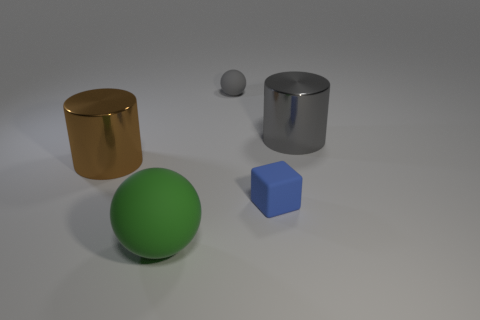Add 2 brown objects. How many objects exist? 7 Subtract all gray spheres. How many spheres are left? 1 Subtract all spheres. How many objects are left? 3 Subtract 1 cylinders. How many cylinders are left? 1 Subtract all gray cylinders. Subtract all blue balls. How many cylinders are left? 1 Subtract all blue cylinders. How many gray balls are left? 1 Subtract all small purple balls. Subtract all cylinders. How many objects are left? 3 Add 4 cylinders. How many cylinders are left? 6 Add 2 tiny blue cylinders. How many tiny blue cylinders exist? 2 Subtract 0 green cubes. How many objects are left? 5 